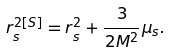Convert formula to latex. <formula><loc_0><loc_0><loc_500><loc_500>r ^ { 2 [ S ] } _ { s } = r ^ { 2 } _ { s } + \frac { 3 } { 2 M ^ { 2 } } \mu _ { s } .</formula> 